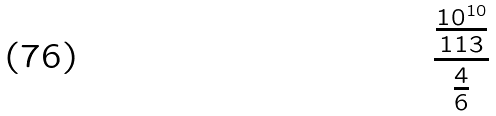<formula> <loc_0><loc_0><loc_500><loc_500>\frac { \frac { 1 0 ^ { 1 0 } } { 1 1 3 } } { \frac { 4 } { 6 } }</formula> 